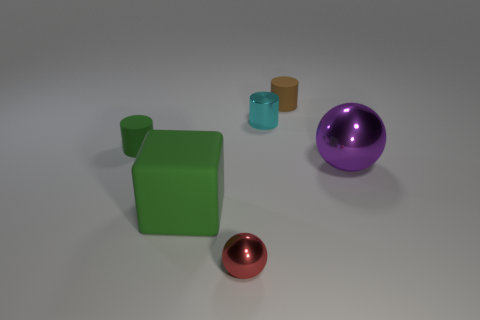Do the small green object and the small cyan object have the same shape?
Keep it short and to the point. Yes. How many other things are the same size as the cyan cylinder?
Ensure brevity in your answer.  3. What number of things are green rubber things that are behind the large green cube or small rubber things that are to the left of the cube?
Give a very brief answer. 1. How many brown objects have the same shape as the purple metal object?
Provide a succinct answer. 0. What is the material of the object that is on the right side of the cyan shiny cylinder and left of the big purple sphere?
Offer a very short reply. Rubber. How many balls are behind the purple ball?
Give a very brief answer. 0. What number of tiny shiny things are there?
Your response must be concise. 2. Do the green block and the cyan metallic cylinder have the same size?
Offer a terse response. No. There is a tiny rubber cylinder that is in front of the small rubber thing that is behind the tiny green rubber cylinder; is there a purple metallic thing behind it?
Your answer should be very brief. No. What material is the other red object that is the same shape as the big shiny object?
Ensure brevity in your answer.  Metal. 